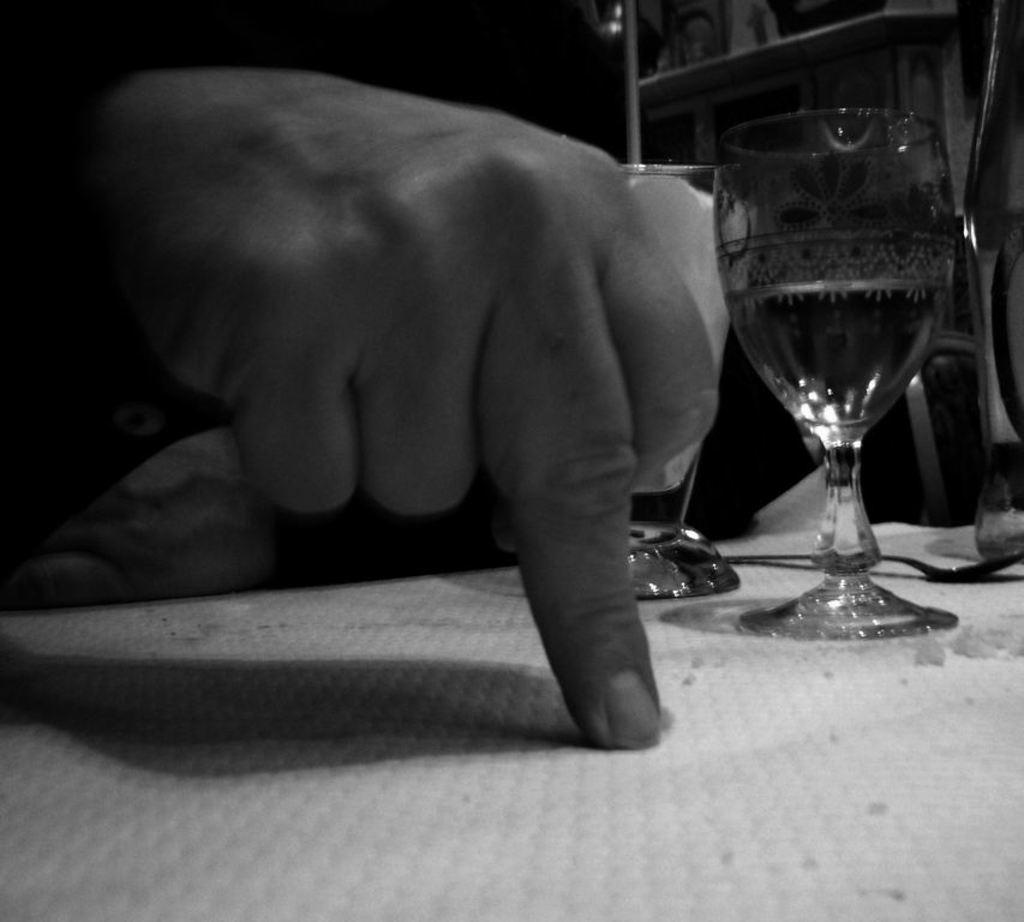What is the main subject of the image? There is a person in the image. What is the person doing in the image? The person is pointing a finger on the table. What else can be seen on the table? There is a wine glass on the table. What is the color scheme of the image? The image is in black and white color. What type of mine can be seen in the image? There is no mine present in the image. What is the person regretting in the image? There is no indication of regret in the image; the person is simply pointing a finger on the table. 